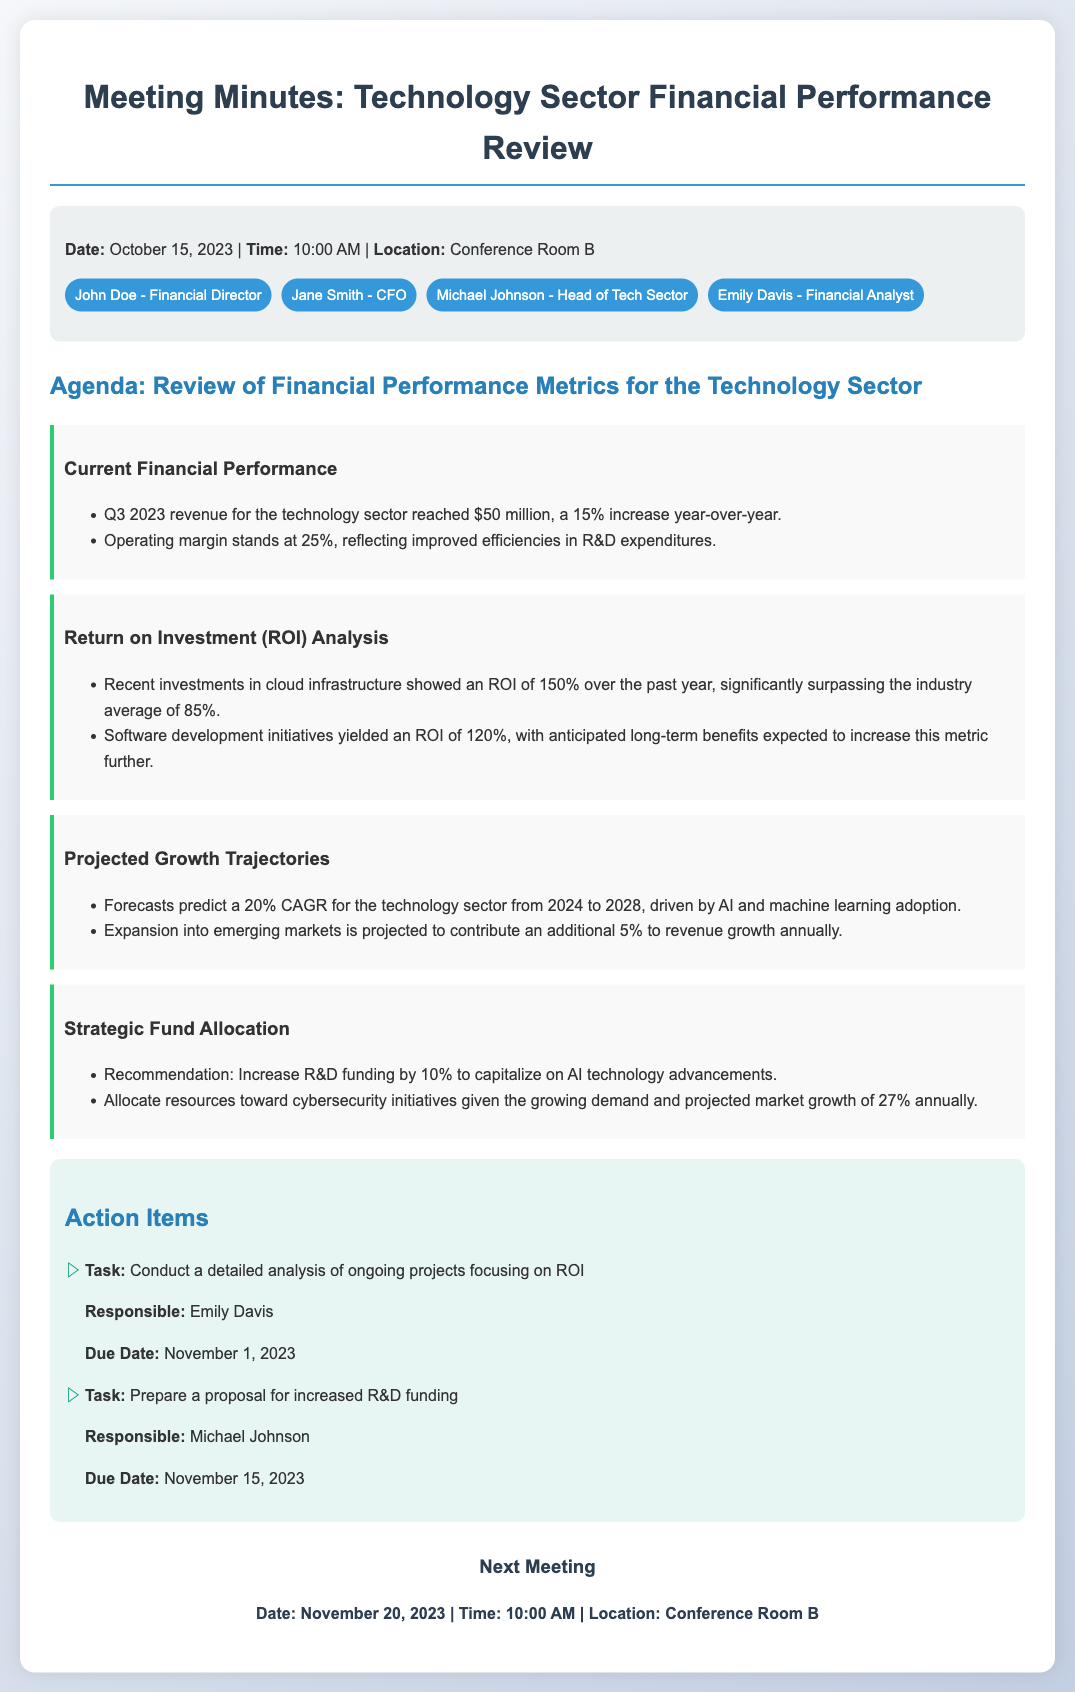What was the revenue for Q3 2023? The Q3 2023 revenue reached $50 million, as stated in the document.
Answer: $50 million What is the operating margin for the technology sector? The document states that the operating margin stands at 25%.
Answer: 25% What is the ROI for cloud infrastructure investments? According to the meeting minutes, the ROI for cloud infrastructure investments is 150%.
Answer: 150% What is the projected CAGR for the technology sector from 2024 to 2028? The forecast predicts a 20% CAGR for the technology sector during this period.
Answer: 20% When is the next meeting scheduled? The next meeting date mentioned in the document is November 20, 2023.
Answer: November 20, 2023 Who is responsible for analyzing ongoing projects focusing on ROI? Emily Davis is responsible for this task as per the action items listed.
Answer: Emily Davis What percentage increase in R&D funding is recommended? The meeting minutes recommend a 10% increase in R&D funding.
Answer: 10% What additional revenue growth percentage is projected from expansion into emerging markets? The document projects an additional 5% revenue growth from this expansion.
Answer: 5% What is the projected market growth for cybersecurity initiatives annually? The projected market growth for cybersecurity initiatives is stated to be 27% annually.
Answer: 27% 